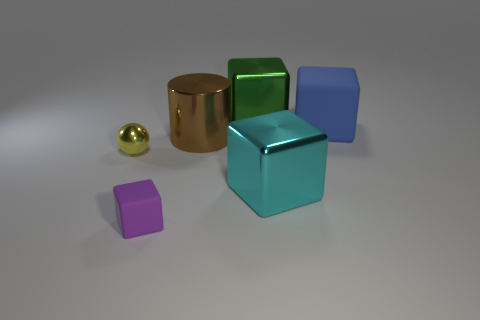There is a thing that is both in front of the sphere and behind the purple thing; what size is it?
Provide a short and direct response. Large. There is a thing that is on the left side of the purple rubber block; are there any tiny yellow shiny spheres to the right of it?
Keep it short and to the point. No. There is a big brown metallic object; how many large blue rubber things are to the right of it?
Provide a succinct answer. 1. There is a small rubber thing that is the same shape as the large green object; what is its color?
Provide a succinct answer. Purple. Is the object right of the cyan metal object made of the same material as the cube that is to the left of the green metallic object?
Your answer should be compact. Yes. Does the big shiny cylinder have the same color as the rubber thing right of the brown cylinder?
Ensure brevity in your answer.  No. There is a metallic object that is left of the large green thing and on the right side of the purple rubber thing; what shape is it?
Provide a succinct answer. Cylinder. How many rubber cubes are there?
Offer a terse response. 2. The cyan thing that is the same shape as the large green object is what size?
Ensure brevity in your answer.  Large. Is the shape of the metal object behind the big brown metal thing the same as  the big cyan metal object?
Make the answer very short. Yes. 